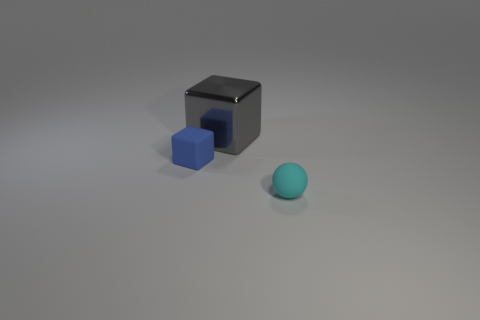There is a object in front of the tiny blue block; is its color the same as the matte cube?
Provide a short and direct response. No. The blue object has what size?
Provide a succinct answer. Small. What is the material of the object that is the same size as the sphere?
Keep it short and to the point. Rubber. What is the color of the block left of the gray metal block?
Your response must be concise. Blue. What number of large rubber balls are there?
Your answer should be compact. 0. Are there any big things behind the cube to the right of the cube that is in front of the gray metallic block?
Provide a succinct answer. No. There is a blue rubber thing that is the same size as the cyan rubber sphere; what is its shape?
Your answer should be compact. Cube. What number of other objects are the same color as the matte block?
Make the answer very short. 0. What material is the cyan thing?
Your answer should be very brief. Rubber. What number of other things are there of the same material as the tiny cyan object
Your response must be concise. 1. 